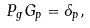Convert formula to latex. <formula><loc_0><loc_0><loc_500><loc_500>P _ { g } G _ { p } = \delta _ { p } ,</formula> 